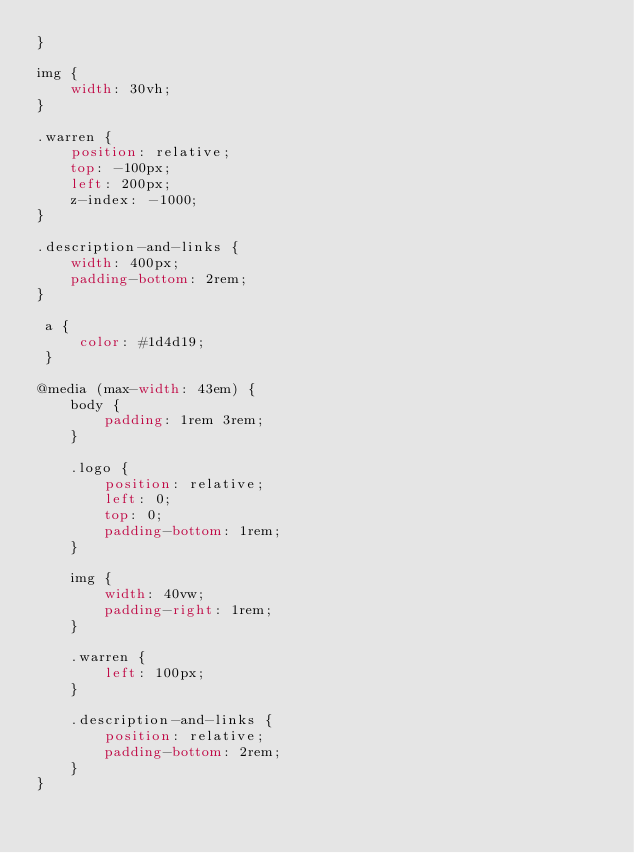<code> <loc_0><loc_0><loc_500><loc_500><_CSS_>}

img {
    width: 30vh;
}

.warren {
    position: relative;
    top: -100px;
    left: 200px;
    z-index: -1000;
}

.description-and-links {
    width: 400px;
    padding-bottom: 2rem;
}

 a {
     color: #1d4d19;
 }

@media (max-width: 43em) {
    body {
        padding: 1rem 3rem;
    }

    .logo {
        position: relative;
        left: 0;
        top: 0;
        padding-bottom: 1rem;
    }

    img {
        width: 40vw;
        padding-right: 1rem;
    }

    .warren {
        left: 100px;
    }

    .description-and-links {
        position: relative;
        padding-bottom: 2rem;
    }
}</code> 